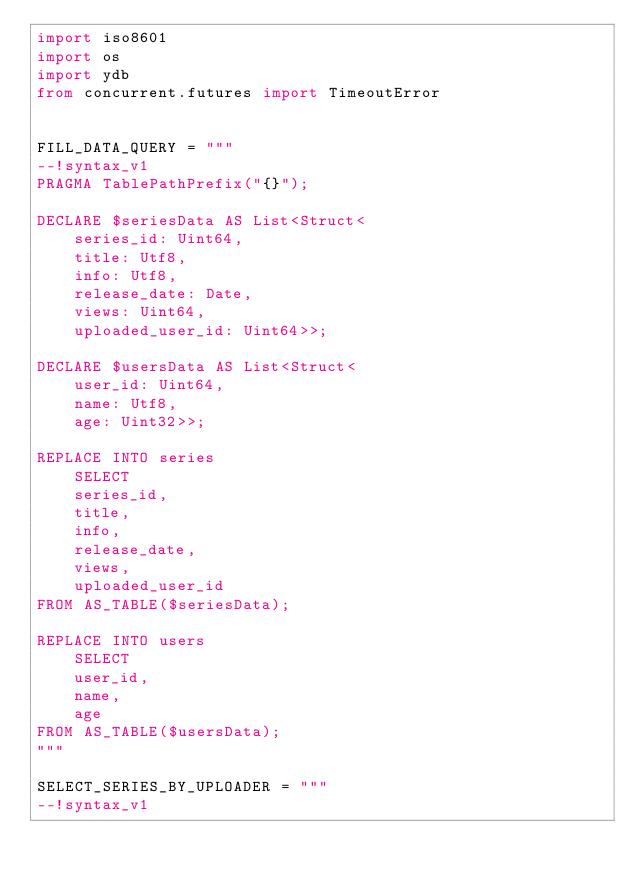Convert code to text. <code><loc_0><loc_0><loc_500><loc_500><_Python_>import iso8601
import os
import ydb
from concurrent.futures import TimeoutError


FILL_DATA_QUERY = """
--!syntax_v1
PRAGMA TablePathPrefix("{}");

DECLARE $seriesData AS List<Struct<
    series_id: Uint64,
    title: Utf8,
    info: Utf8,
    release_date: Date,
    views: Uint64,
    uploaded_user_id: Uint64>>;

DECLARE $usersData AS List<Struct<
    user_id: Uint64,
    name: Utf8,
    age: Uint32>>;

REPLACE INTO series
    SELECT
    series_id,
    title,
    info,
    release_date,
    views,
    uploaded_user_id
FROM AS_TABLE($seriesData);

REPLACE INTO users
    SELECT
    user_id,
    name,
    age
FROM AS_TABLE($usersData);
"""

SELECT_SERIES_BY_UPLOADER = """
--!syntax_v1</code> 